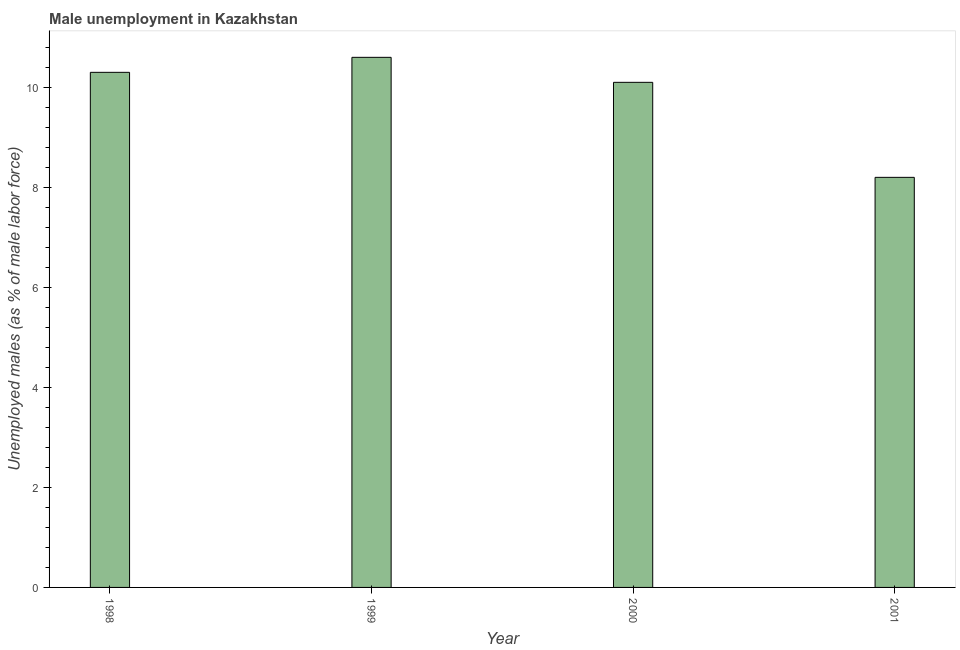Does the graph contain any zero values?
Your response must be concise. No. What is the title of the graph?
Provide a short and direct response. Male unemployment in Kazakhstan. What is the label or title of the X-axis?
Offer a terse response. Year. What is the label or title of the Y-axis?
Keep it short and to the point. Unemployed males (as % of male labor force). What is the unemployed males population in 1999?
Your answer should be very brief. 10.6. Across all years, what is the maximum unemployed males population?
Your answer should be very brief. 10.6. Across all years, what is the minimum unemployed males population?
Keep it short and to the point. 8.2. In which year was the unemployed males population minimum?
Ensure brevity in your answer.  2001. What is the sum of the unemployed males population?
Ensure brevity in your answer.  39.2. What is the difference between the unemployed males population in 2000 and 2001?
Your response must be concise. 1.9. What is the median unemployed males population?
Ensure brevity in your answer.  10.2. In how many years, is the unemployed males population greater than 7.2 %?
Make the answer very short. 4. What is the ratio of the unemployed males population in 2000 to that in 2001?
Your answer should be compact. 1.23. How many bars are there?
Your answer should be very brief. 4. How many years are there in the graph?
Provide a succinct answer. 4. What is the difference between two consecutive major ticks on the Y-axis?
Keep it short and to the point. 2. Are the values on the major ticks of Y-axis written in scientific E-notation?
Make the answer very short. No. What is the Unemployed males (as % of male labor force) of 1998?
Ensure brevity in your answer.  10.3. What is the Unemployed males (as % of male labor force) of 1999?
Your response must be concise. 10.6. What is the Unemployed males (as % of male labor force) of 2000?
Offer a very short reply. 10.1. What is the Unemployed males (as % of male labor force) of 2001?
Ensure brevity in your answer.  8.2. What is the difference between the Unemployed males (as % of male labor force) in 1998 and 1999?
Provide a short and direct response. -0.3. What is the difference between the Unemployed males (as % of male labor force) in 1998 and 2000?
Make the answer very short. 0.2. What is the difference between the Unemployed males (as % of male labor force) in 1998 and 2001?
Offer a terse response. 2.1. What is the difference between the Unemployed males (as % of male labor force) in 1999 and 2001?
Offer a very short reply. 2.4. What is the difference between the Unemployed males (as % of male labor force) in 2000 and 2001?
Offer a very short reply. 1.9. What is the ratio of the Unemployed males (as % of male labor force) in 1998 to that in 1999?
Your answer should be compact. 0.97. What is the ratio of the Unemployed males (as % of male labor force) in 1998 to that in 2000?
Your answer should be very brief. 1.02. What is the ratio of the Unemployed males (as % of male labor force) in 1998 to that in 2001?
Provide a succinct answer. 1.26. What is the ratio of the Unemployed males (as % of male labor force) in 1999 to that in 2000?
Keep it short and to the point. 1.05. What is the ratio of the Unemployed males (as % of male labor force) in 1999 to that in 2001?
Offer a very short reply. 1.29. What is the ratio of the Unemployed males (as % of male labor force) in 2000 to that in 2001?
Offer a terse response. 1.23. 